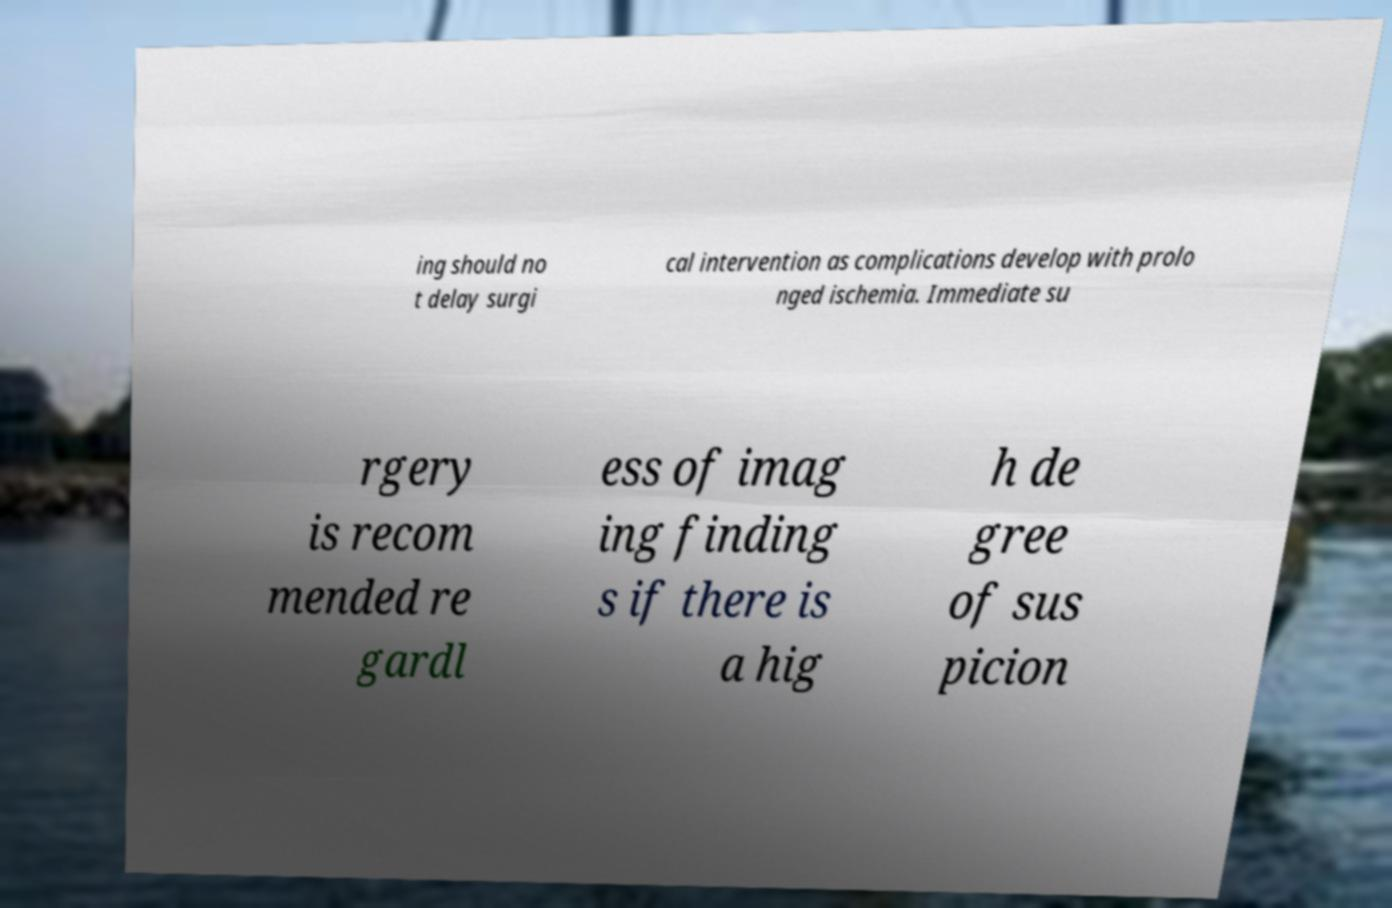For documentation purposes, I need the text within this image transcribed. Could you provide that? ing should no t delay surgi cal intervention as complications develop with prolo nged ischemia. Immediate su rgery is recom mended re gardl ess of imag ing finding s if there is a hig h de gree of sus picion 